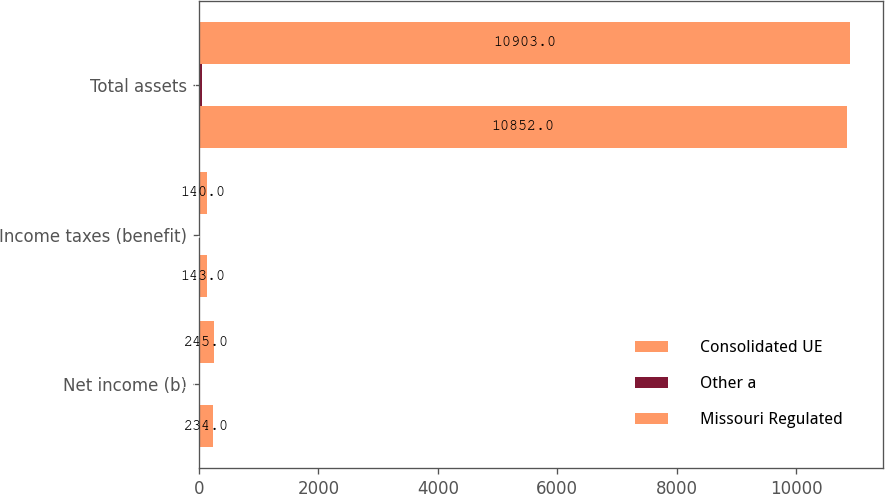Convert chart to OTSL. <chart><loc_0><loc_0><loc_500><loc_500><stacked_bar_chart><ecel><fcel>Net income (b)<fcel>Income taxes (benefit)<fcel>Total assets<nl><fcel>Consolidated UE<fcel>234<fcel>143<fcel>10852<nl><fcel>Other a<fcel>11<fcel>3<fcel>51<nl><fcel>Missouri Regulated<fcel>245<fcel>140<fcel>10903<nl></chart> 